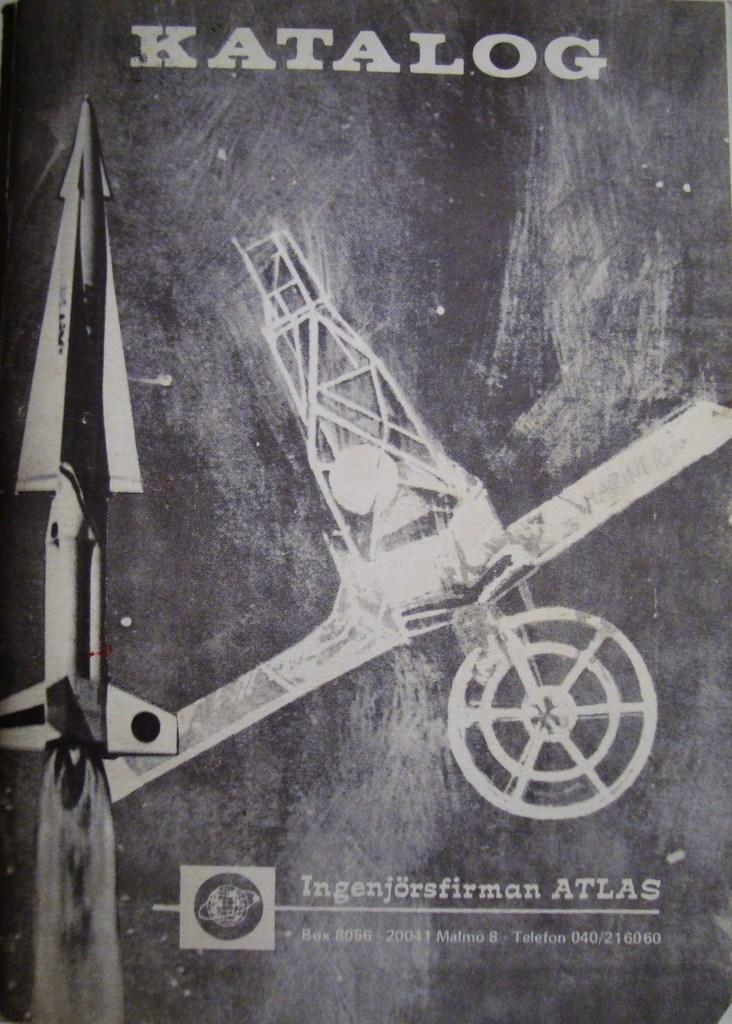What is the color scheme of the poster in the image? The poster is black and white. What word is written at the top of the poster? The word "Katalog" is written at the top of the poster. What can be seen at the center of the poster? There are two aeroplanes at the center of the poster. Can you see a frog jumping on the aeroplanes in the image? No, there is no frog present in the image, and the aeroplanes are not depicted as having any living creatures on them. Is there any indication of a pest problem in the image? No, there is no mention or depiction of any pest problem in the image. 